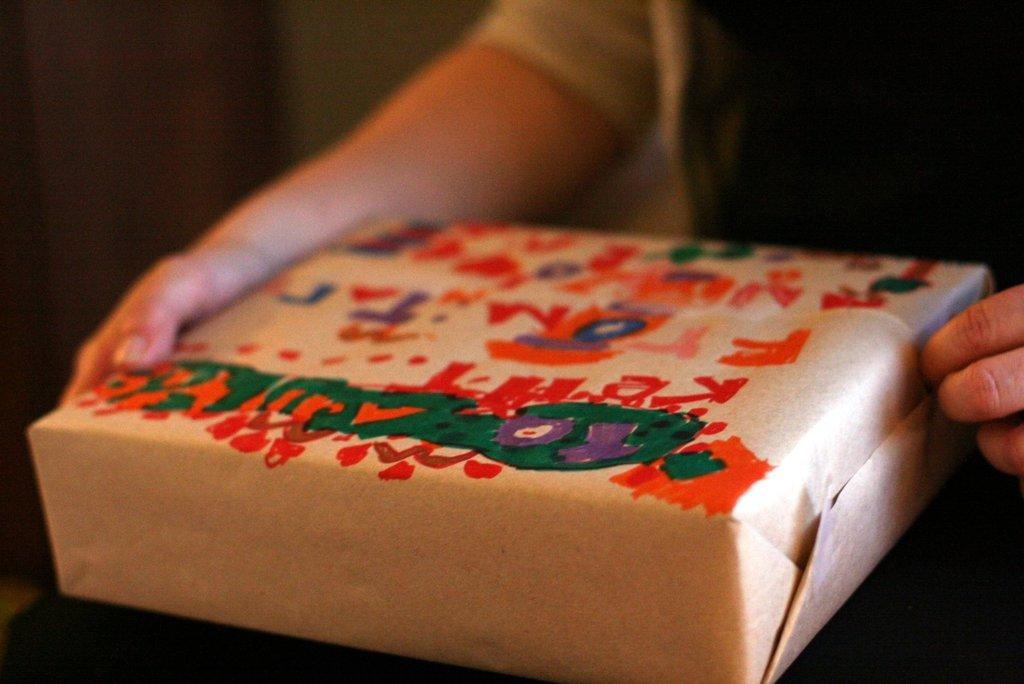What is the person in the image holding? The person is holding an object in the image. What can be seen on the surface of the object? There is a painting on the object. Can you describe the background of the image? The background of the image is blurred. How does the person blow up the bomb in the image? There is no bomb present in the image, and the person is not blowing anything up. 